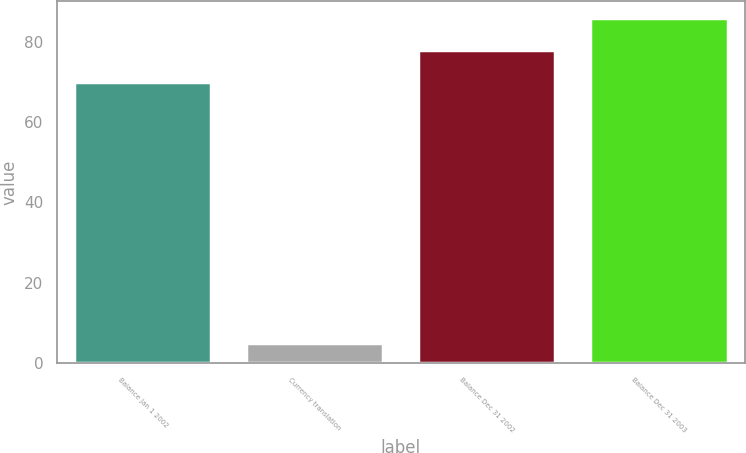Convert chart. <chart><loc_0><loc_0><loc_500><loc_500><bar_chart><fcel>Balance Jan 1 2002<fcel>Currency translation<fcel>Balance Dec 31 2002<fcel>Balance Dec 31 2003<nl><fcel>70<fcel>5<fcel>77.9<fcel>85.8<nl></chart> 